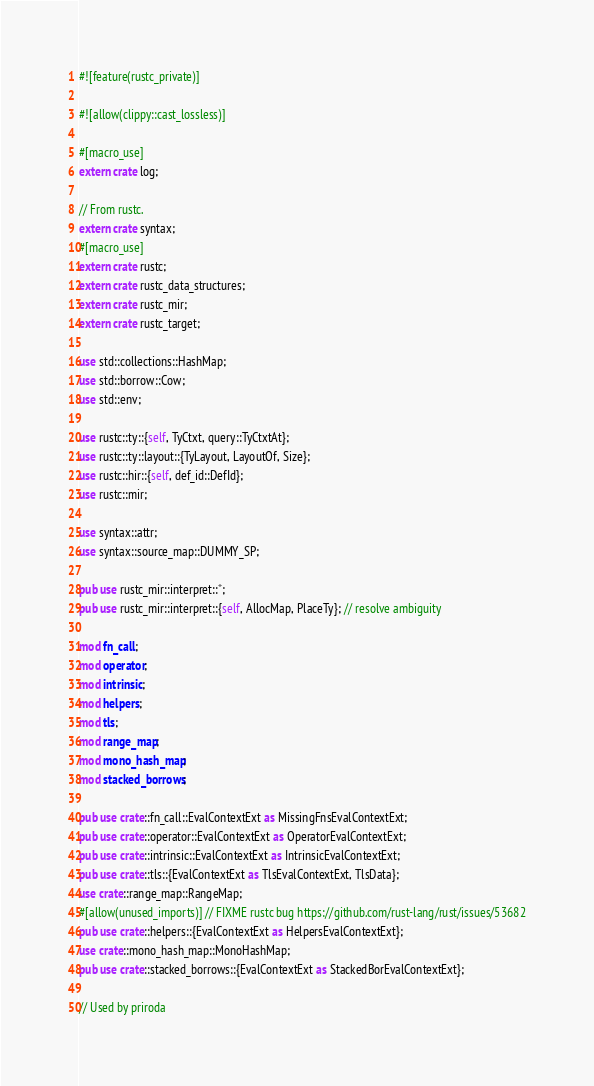Convert code to text. <code><loc_0><loc_0><loc_500><loc_500><_Rust_>#![feature(rustc_private)]

#![allow(clippy::cast_lossless)]

#[macro_use]
extern crate log;

// From rustc.
extern crate syntax;
#[macro_use]
extern crate rustc;
extern crate rustc_data_structures;
extern crate rustc_mir;
extern crate rustc_target;

use std::collections::HashMap;
use std::borrow::Cow;
use std::env;

use rustc::ty::{self, TyCtxt, query::TyCtxtAt};
use rustc::ty::layout::{TyLayout, LayoutOf, Size};
use rustc::hir::{self, def_id::DefId};
use rustc::mir;

use syntax::attr;
use syntax::source_map::DUMMY_SP;

pub use rustc_mir::interpret::*;
pub use rustc_mir::interpret::{self, AllocMap, PlaceTy}; // resolve ambiguity

mod fn_call;
mod operator;
mod intrinsic;
mod helpers;
mod tls;
mod range_map;
mod mono_hash_map;
mod stacked_borrows;

pub use crate::fn_call::EvalContextExt as MissingFnsEvalContextExt;
pub use crate::operator::EvalContextExt as OperatorEvalContextExt;
pub use crate::intrinsic::EvalContextExt as IntrinsicEvalContextExt;
pub use crate::tls::{EvalContextExt as TlsEvalContextExt, TlsData};
use crate::range_map::RangeMap;
#[allow(unused_imports)] // FIXME rustc bug https://github.com/rust-lang/rust/issues/53682
pub use crate::helpers::{EvalContextExt as HelpersEvalContextExt};
use crate::mono_hash_map::MonoHashMap;
pub use crate::stacked_borrows::{EvalContextExt as StackedBorEvalContextExt};

// Used by priroda</code> 